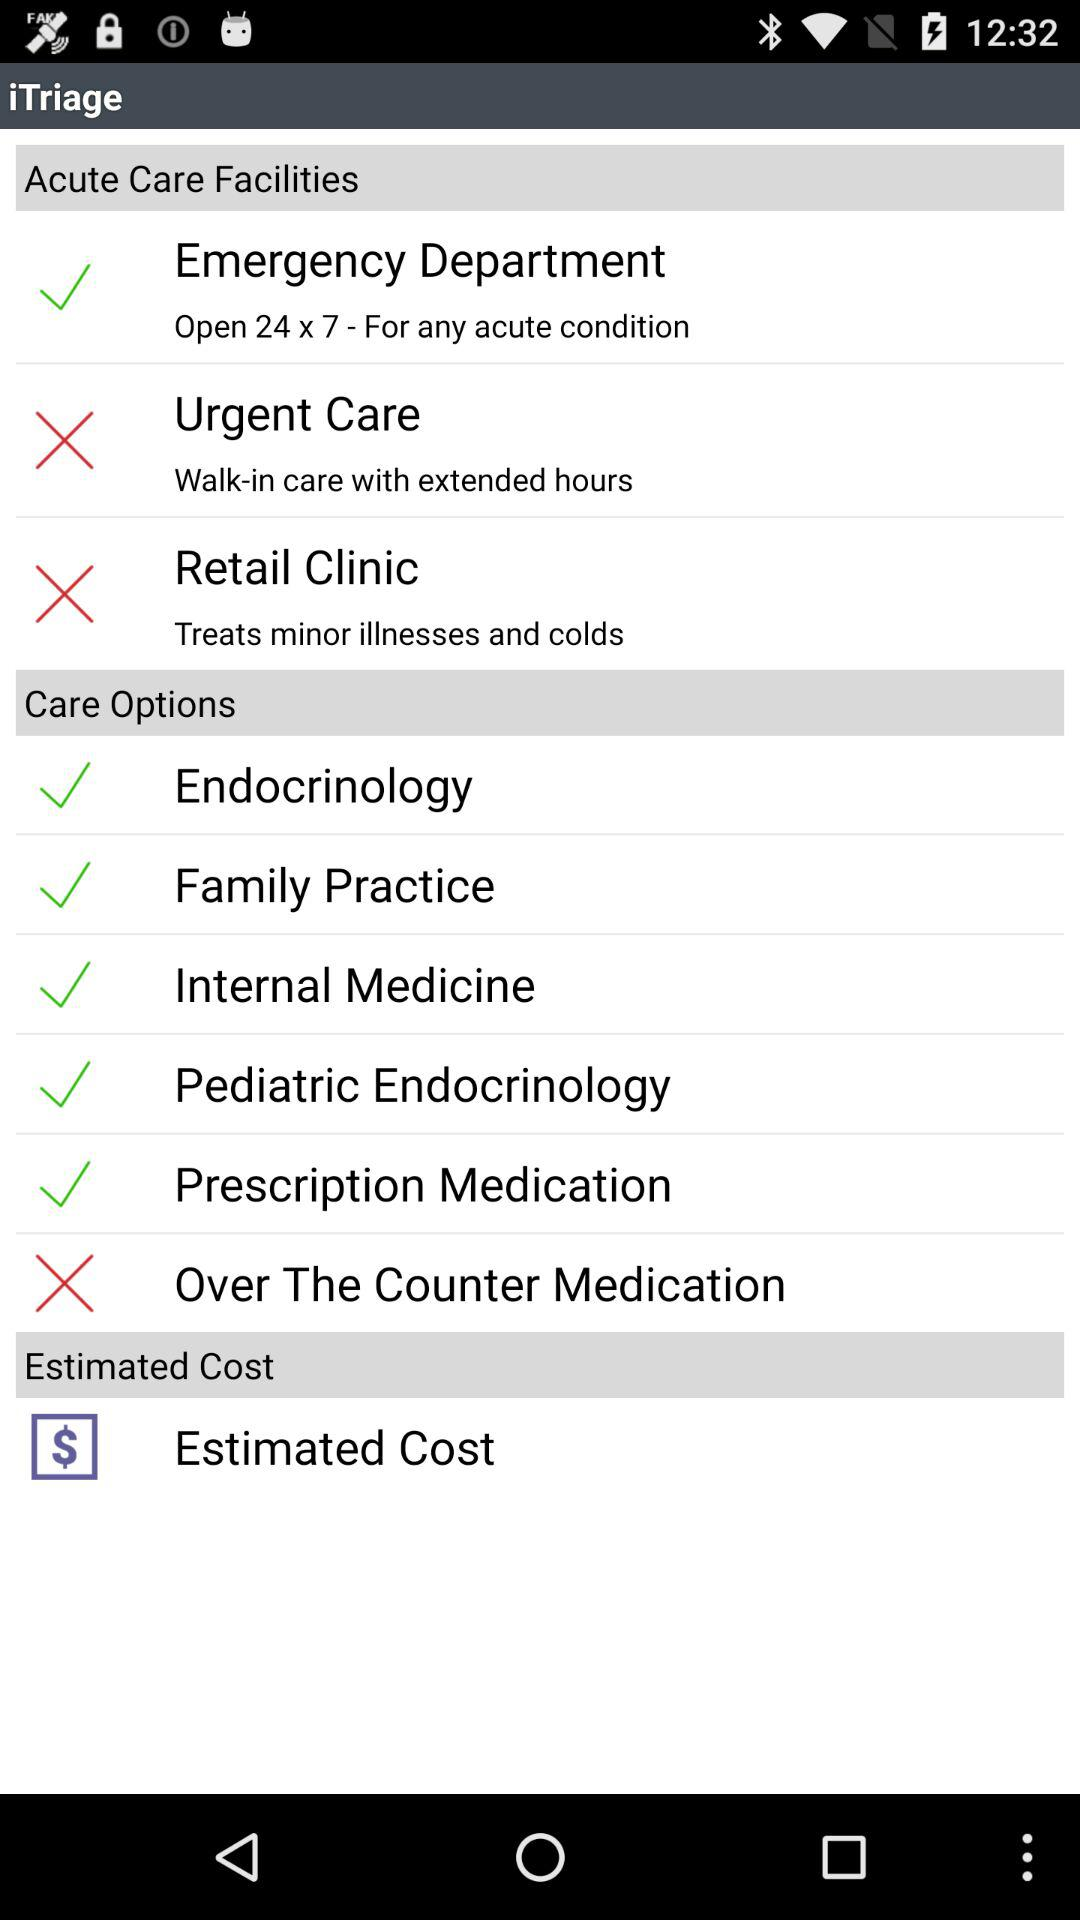What is the currency of the estimated cost? The currency of the estimated cost is $. 